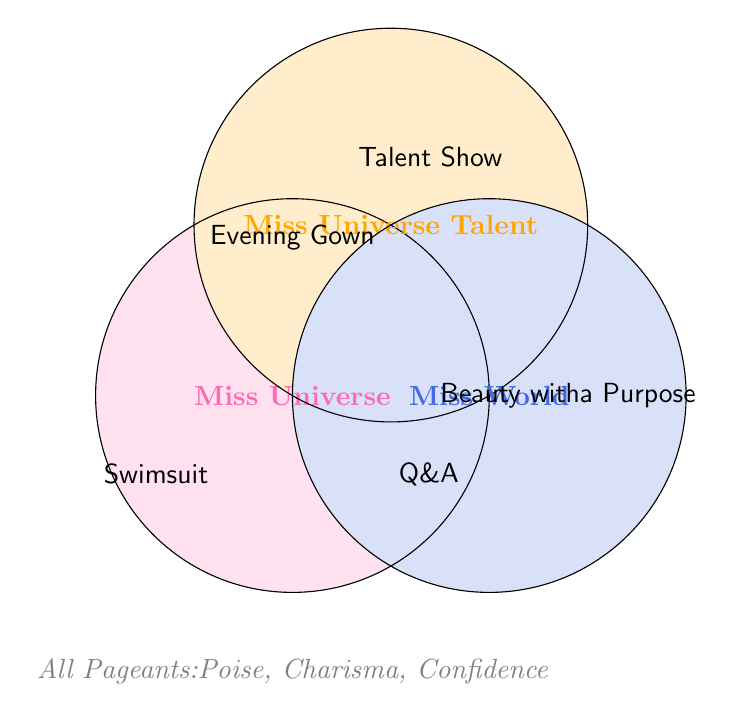What are the common elements among all three beauty pageants (Miss Universe, Miss Universe Talent, and Miss World)? The diagram shows where all three circles overlap. The common elements in the overlapping section are Evening Gown, Swimsuit, and Q&A.
Answer: Evening Gown, Swimsuit, Q&A Which category is unique to Miss World? The section where only the Miss World circle is colored without intersecting with the other circles contains 'Beauty with a Purpose.'
Answer: Beauty with a Purpose Which categories exist exclusively in the 'All Pageants' section without overlapping with any specific pageant circles? The elements listed under 'All Pageants' at the bottom of the figure are Poise, Charisma, and Confidence. These are outside the three main circles.
Answer: Poise, Charisma, Confidence Which pageant includes a Talent Show as one of its categories? The Talent Show is included within the circle labeled 'Miss Universe Talent.'
Answer: Miss Universe Talent What categories do both Miss Universe and Miss World share, excluding Miss Universe Talent? The overlap between the Miss Universe and Miss World circles shows the shared categories as Evening Gown, Swimsuit, and Q&A.
Answer: Evening Gown, Swimsuit, Q&A How many unique categories does Miss Universe Talent have compared to Miss Universe? By comparing the areas of the circles, Miss Universe has 3 unique categories (Evening Gown, Swimsuit, Q&A), while Miss Universe Talent includes the unique addition of Talent Show. So, it has 1 more unique category.
Answer: 1 Which circle encompasses the most categories unique to itself? Miss Universe Talent has the unique category 'Talent Show,' while Miss World has 'Beauty with a Purpose' and all others are shared. Count the unique items, Miss World thus encompasses one item more uniquely than Miss Universe Talent.
Answer: Miss World Which categories do Miss Universe and Miss Universe Talent share but are not common to Miss World? Referring to the overlap section between Miss Universe and Miss Universe Talent but excluding Miss World, they share Evening Gown, Swimsuit, and Q&A.
Answer: Evening Gown, Swimsuit, Q&A How many categories are shared across all pageants on the diagram? Look at the bottom of the diagram under 'All Pageants' which lists Poise, Charisma, and Confidence. These three categories are shared across all pageants.
Answer: 3 